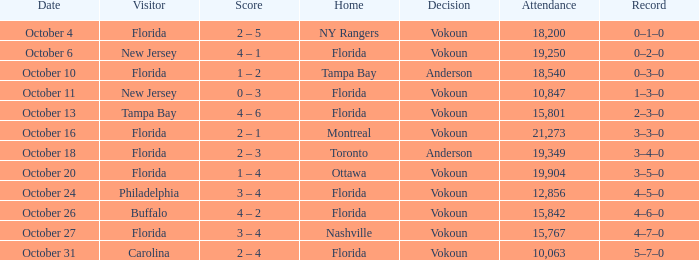Which team triumphed when the visiting side was carolina? Vokoun. 